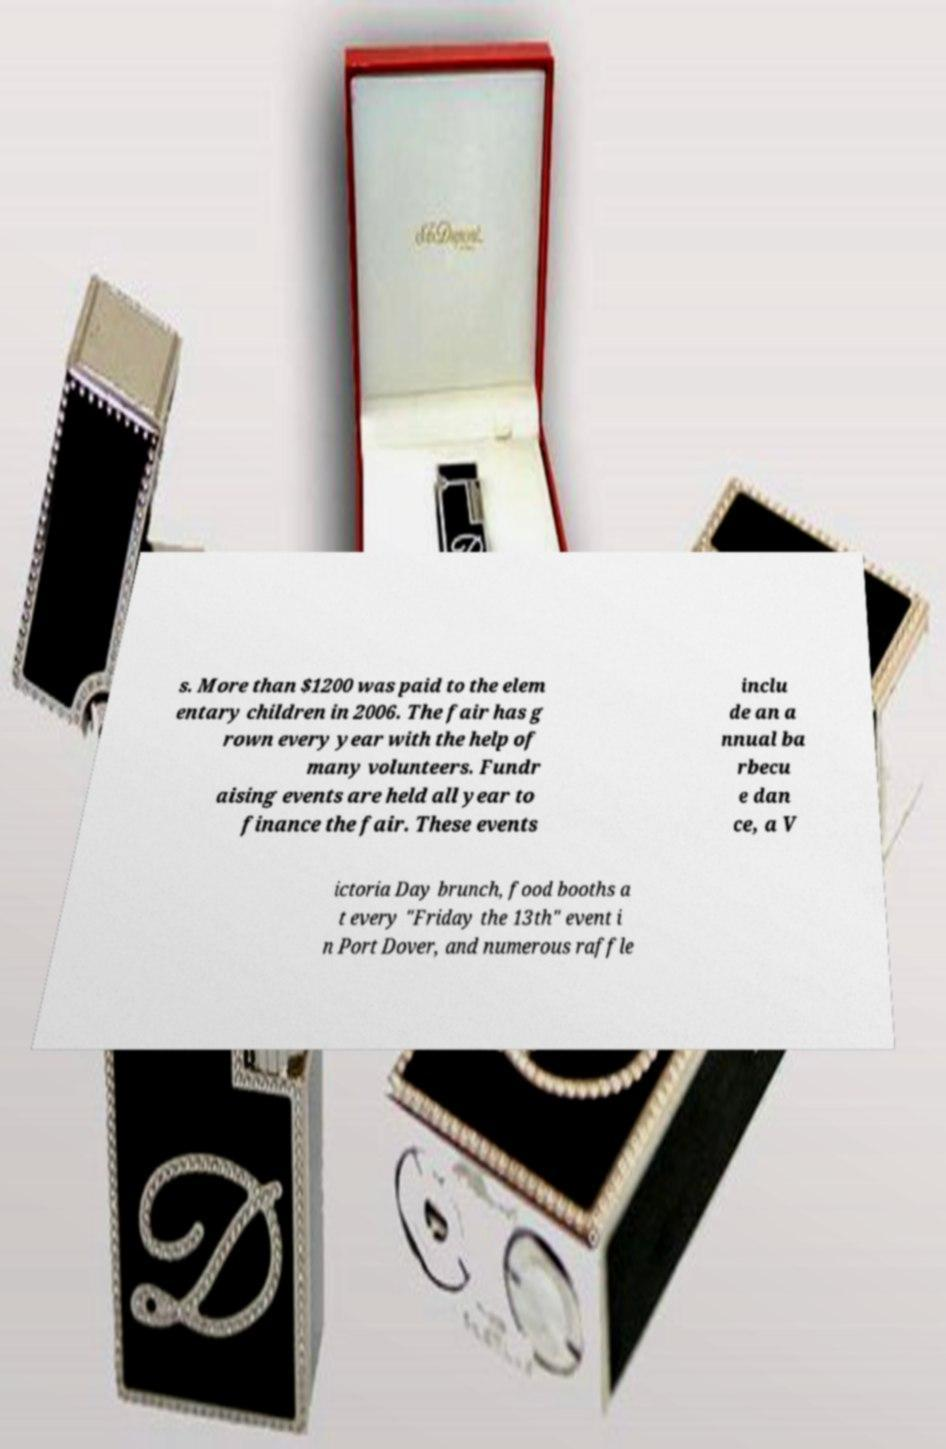I need the written content from this picture converted into text. Can you do that? s. More than $1200 was paid to the elem entary children in 2006. The fair has g rown every year with the help of many volunteers. Fundr aising events are held all year to finance the fair. These events inclu de an a nnual ba rbecu e dan ce, a V ictoria Day brunch, food booths a t every "Friday the 13th" event i n Port Dover, and numerous raffle 